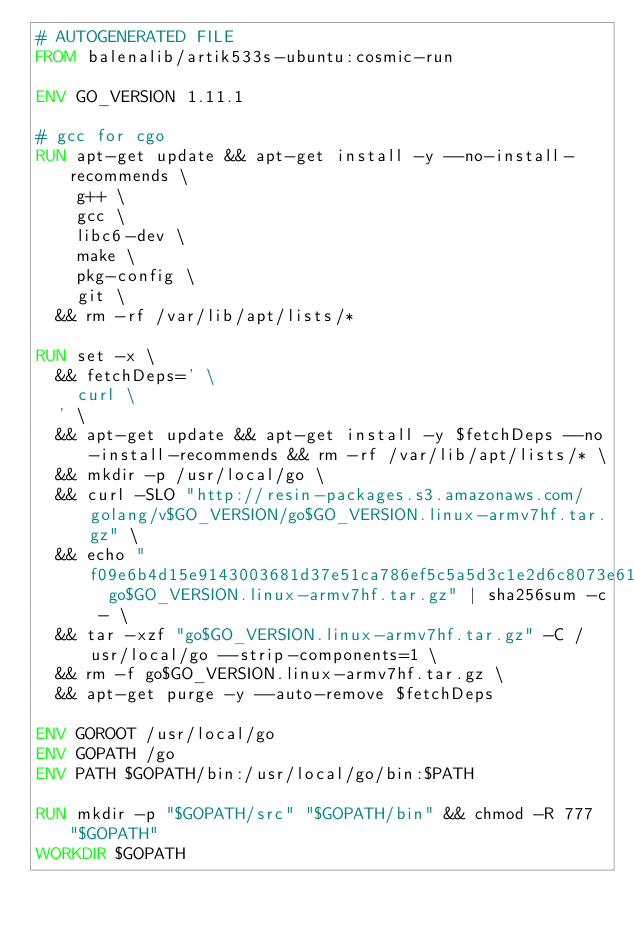Convert code to text. <code><loc_0><loc_0><loc_500><loc_500><_Dockerfile_># AUTOGENERATED FILE
FROM balenalib/artik533s-ubuntu:cosmic-run

ENV GO_VERSION 1.11.1

# gcc for cgo
RUN apt-get update && apt-get install -y --no-install-recommends \
		g++ \
		gcc \
		libc6-dev \
		make \
		pkg-config \
		git \
	&& rm -rf /var/lib/apt/lists/*

RUN set -x \
	&& fetchDeps=' \
		curl \
	' \
	&& apt-get update && apt-get install -y $fetchDeps --no-install-recommends && rm -rf /var/lib/apt/lists/* \
	&& mkdir -p /usr/local/go \
	&& curl -SLO "http://resin-packages.s3.amazonaws.com/golang/v$GO_VERSION/go$GO_VERSION.linux-armv7hf.tar.gz" \
	&& echo "f09e6b4d15e9143003681d37e51ca786ef5c5a5d3c1e2d6c8073e61c823b8c1a  go$GO_VERSION.linux-armv7hf.tar.gz" | sha256sum -c - \
	&& tar -xzf "go$GO_VERSION.linux-armv7hf.tar.gz" -C /usr/local/go --strip-components=1 \
	&& rm -f go$GO_VERSION.linux-armv7hf.tar.gz \
	&& apt-get purge -y --auto-remove $fetchDeps

ENV GOROOT /usr/local/go
ENV GOPATH /go
ENV PATH $GOPATH/bin:/usr/local/go/bin:$PATH

RUN mkdir -p "$GOPATH/src" "$GOPATH/bin" && chmod -R 777 "$GOPATH"
WORKDIR $GOPATH
</code> 